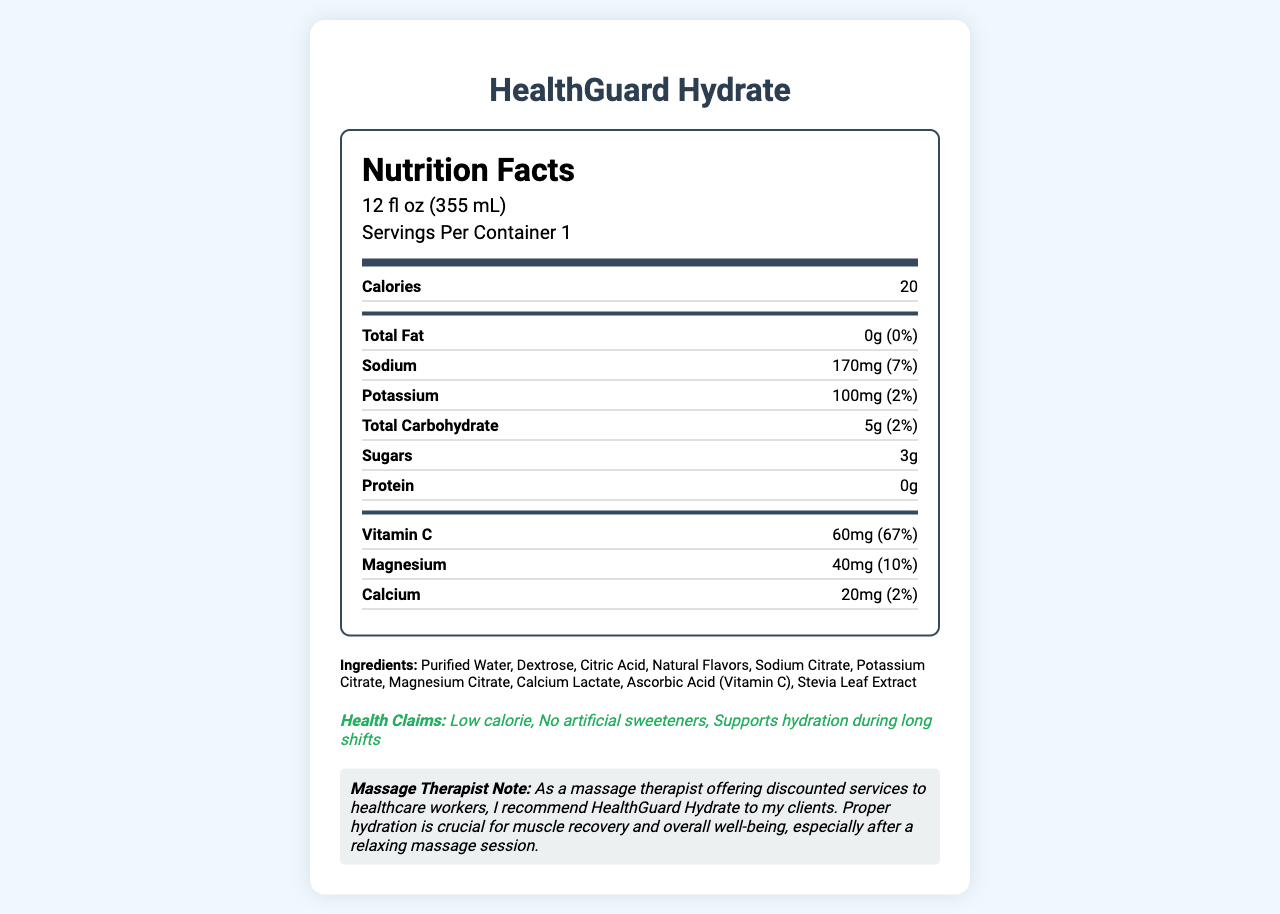what is the product name? The product name, "HealthGuard Hydrate," is displayed prominently at the top of the document, indicating what the Nutrition Facts Label is for.
Answer: HealthGuard Hydrate what is the serving size of HealthGuard Hydrate? The serving size is listed right below the "Nutrition Facts" header as "12 fl oz (355 mL)."
Answer: 12 fl oz (355 mL) how many calories are in one serving? The document lists "Calories 20" in the nutrition label section.
Answer: 20 what is the amount of Vitamin C in one serving? The document specifies "Vitamin C 60mg (67%)" in the nutrient section.
Answer: 60mg how much sodium does HealthGuard Hydrate contain per serving? The sodium content per serving is listed as "170mg (7%)."
Answer: 170mg which ingredient is used as a natural sweetener in HealthGuard Hydrate? Stevia Leaf Extract is listed last in the ingredients section, indicating it is the natural sweetener used.
Answer: Stevia Leaf Extract what percentage of the daily value of magnesium does one serving provide? The document states that each serving provides "Magnesium 40mg (10%)".
Answer: 10% which of the following ingredients is not in HealthGuard Hydrate? A. Sodium Citrate B. Ascorbic Acid C. High Fructose Corn Syrup D. Potassium Citrate The ingredient list includes Sodium Citrate, Ascorbic Acid, and Potassium Citrate but not High Fructose Corn Syrup.
Answer: C. High Fructose Corn Syrup how many grams of protein are in one serving? A. 0g B. 1g C. 5g D. 10g The nutrition label states that the protein content is "0g".
Answer: A. 0g is HealthGuard Hydrate low in calories? One of the health claims listed in the document is "Low calorie."
Answer: Yes summarize the document. This summation covers the key elements of the document, including product details, nutritional information, health benefits, ingredients, and a recommendation note.
Answer: HealthGuard Hydrate is a low-calorie, electrolyte-rich sports drink formulated for healthcare professionals working long hours. It contains 20 calories per serving, no fat or protein, and is rich in Vitamin C and other essential minerals. It includes purified water, dextrose, natural flavors, and Stevia Leaf Extract, among other ingredients. The document provides detailed nutritional information and claims that the drink supports hydration during long shifts. Additionally, a massage therapist recommends it to clients for proper hydration and muscle recovery. what is the daily value percentage of total carbohydrates in one serving? The daily value percentage for total carbohydrates is listed as "2%."
Answer: 2% does HealthGuard Hydrate contain any artificial sweeteners? The health claims section of the document mentions "No artificial sweeteners."
Answer: No what is the facility allergen information for HealthGuard Hydrate? This information is provided under the allergen information section.
Answer: Produced in a facility that processes milk and soy can you determine the price of HealthGuard Hydrate from this document? The document does not provide any pricing information.
Answer: Cannot be determined 